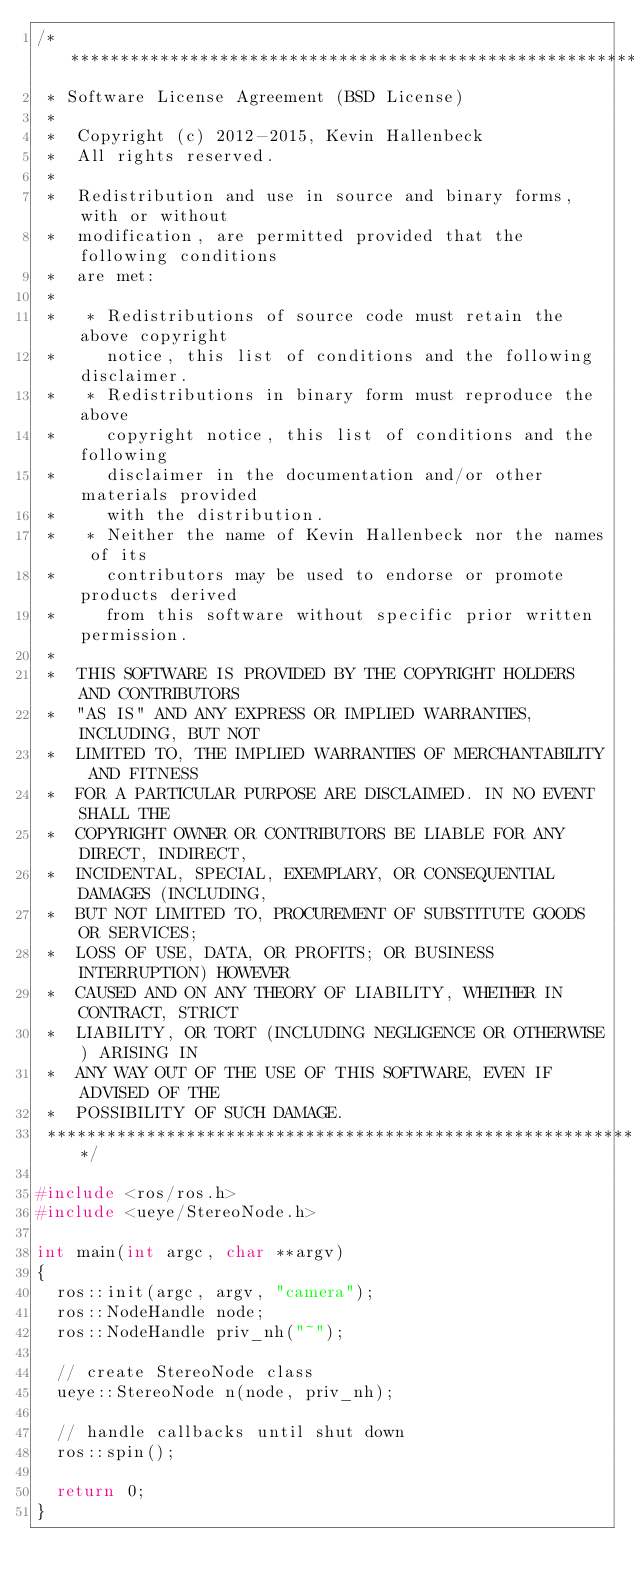Convert code to text. <code><loc_0><loc_0><loc_500><loc_500><_C++_>/*********************************************************************
 * Software License Agreement (BSD License)
 *
 *  Copyright (c) 2012-2015, Kevin Hallenbeck
 *  All rights reserved.
 *
 *  Redistribution and use in source and binary forms, with or without
 *  modification, are permitted provided that the following conditions
 *  are met:
 *
 *   * Redistributions of source code must retain the above copyright
 *     notice, this list of conditions and the following disclaimer.
 *   * Redistributions in binary form must reproduce the above
 *     copyright notice, this list of conditions and the following
 *     disclaimer in the documentation and/or other materials provided
 *     with the distribution.
 *   * Neither the name of Kevin Hallenbeck nor the names of its
 *     contributors may be used to endorse or promote products derived
 *     from this software without specific prior written permission.
 *
 *  THIS SOFTWARE IS PROVIDED BY THE COPYRIGHT HOLDERS AND CONTRIBUTORS
 *  "AS IS" AND ANY EXPRESS OR IMPLIED WARRANTIES, INCLUDING, BUT NOT
 *  LIMITED TO, THE IMPLIED WARRANTIES OF MERCHANTABILITY AND FITNESS
 *  FOR A PARTICULAR PURPOSE ARE DISCLAIMED. IN NO EVENT SHALL THE
 *  COPYRIGHT OWNER OR CONTRIBUTORS BE LIABLE FOR ANY DIRECT, INDIRECT,
 *  INCIDENTAL, SPECIAL, EXEMPLARY, OR CONSEQUENTIAL DAMAGES (INCLUDING,
 *  BUT NOT LIMITED TO, PROCUREMENT OF SUBSTITUTE GOODS OR SERVICES;
 *  LOSS OF USE, DATA, OR PROFITS; OR BUSINESS INTERRUPTION) HOWEVER
 *  CAUSED AND ON ANY THEORY OF LIABILITY, WHETHER IN CONTRACT, STRICT
 *  LIABILITY, OR TORT (INCLUDING NEGLIGENCE OR OTHERWISE) ARISING IN
 *  ANY WAY OUT OF THE USE OF THIS SOFTWARE, EVEN IF ADVISED OF THE
 *  POSSIBILITY OF SUCH DAMAGE.
 *********************************************************************/

#include <ros/ros.h>
#include <ueye/StereoNode.h>

int main(int argc, char **argv)
{
  ros::init(argc, argv, "camera");
  ros::NodeHandle node;
  ros::NodeHandle priv_nh("~");

  // create StereoNode class
  ueye::StereoNode n(node, priv_nh);

  // handle callbacks until shut down
  ros::spin();

  return 0;
}
</code> 